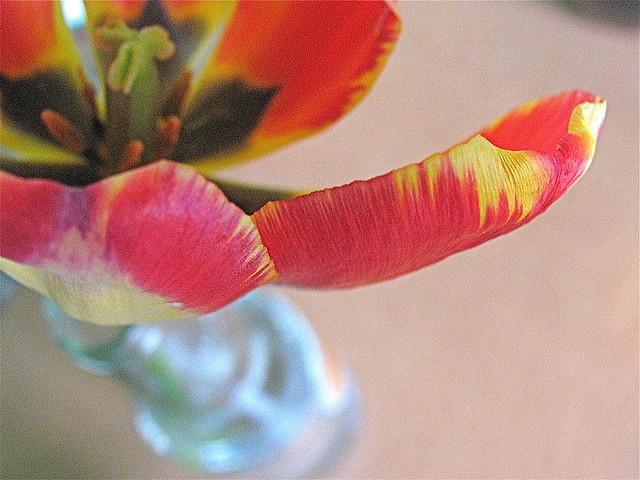Describe the objects in this image and their specific colors. I can see potted plant in red, salmon, darkgray, and brown tones, bottle in red, darkgray, lightblue, and lavender tones, and vase in red, lightblue, darkgray, and lavender tones in this image. 